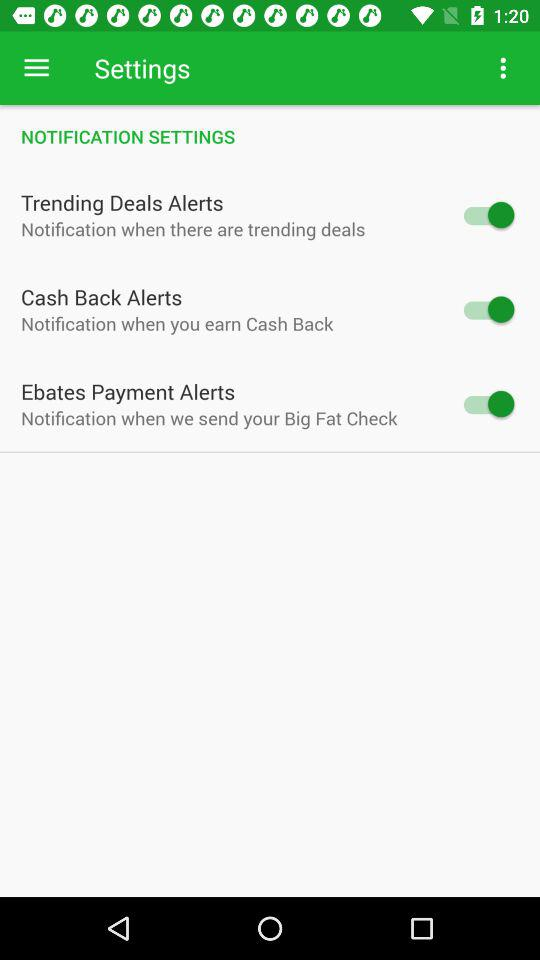What is the status of "Cash Back Alerts"? The status is "on". 